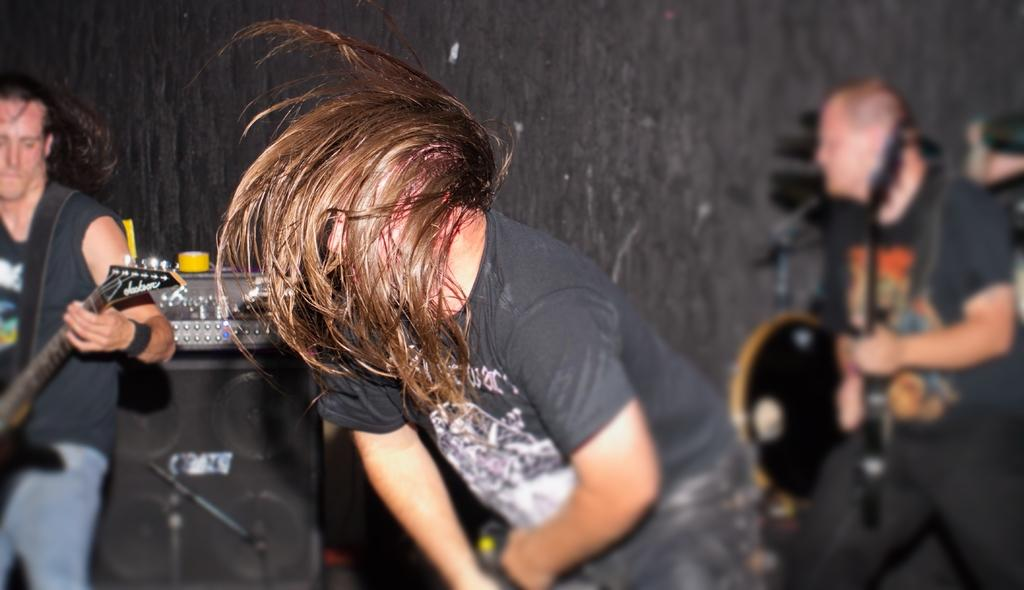What is the main subject of the image? There is a person standing in the image. What is the person holding in the image? The person is holding a guitar in the image. What is the person doing with the guitar? The person is playing music in the image. What type of structure can be seen in the background of the image? There is no structure visible in the background of the image; it only shows a person holding and playing a guitar. 